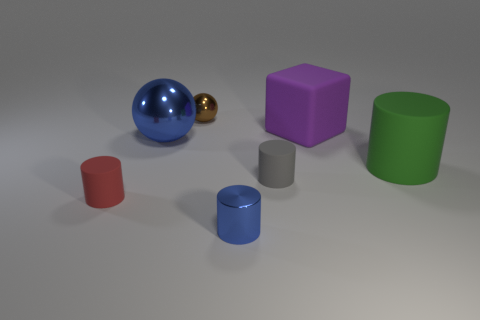Can you describe the lighting in the scene? The lighting in the scene appears to be diffused and soft, providing an even illumination across all objects. There is a subtle shadowing effect under each object, suggesting a light source located above and possibly slightly to the right, creating a calm atmosphere without harsh contrasts. 